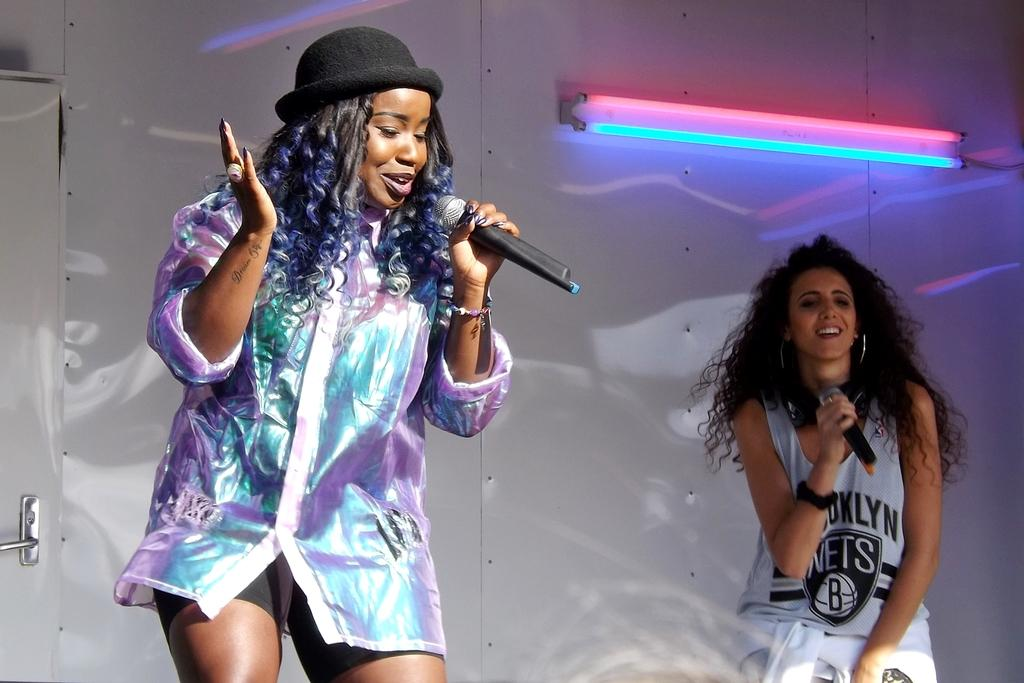How many people are in the image? There are two women in the image. What are the women holding in the image? The women are holding a microphone. What is the emotional state of the women in the image? The women are laughing in the image. What type of oatmeal is being served in the image? There is no oatmeal present in the image; it features two women holding a microphone and laughing. 